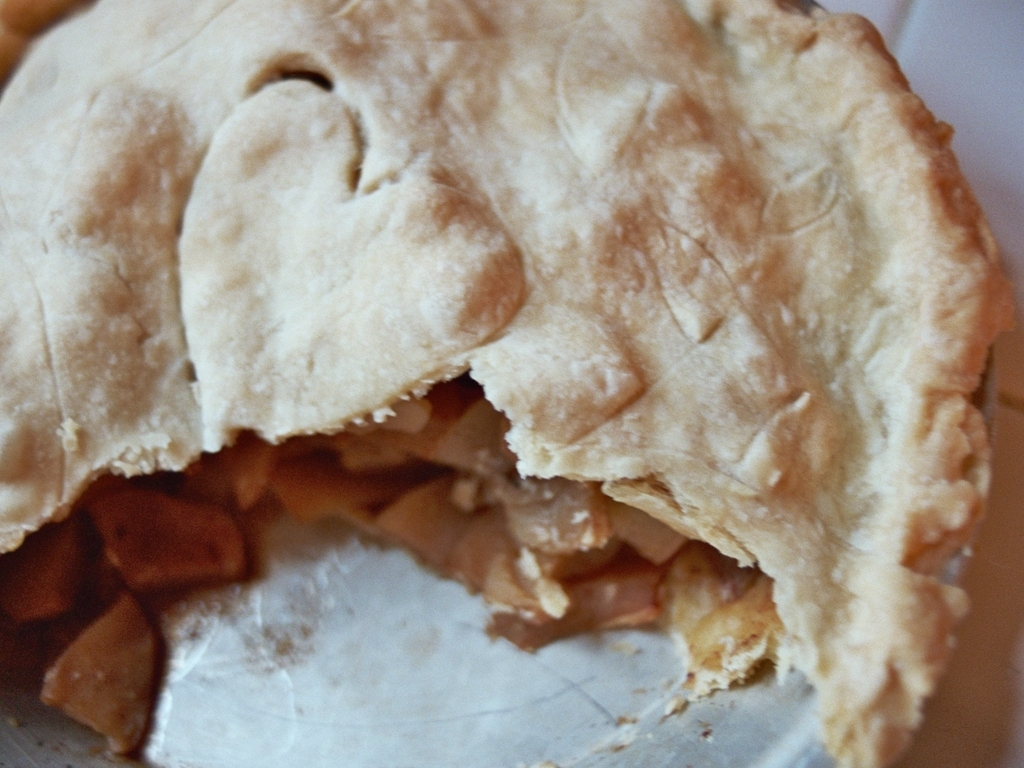Are there any other quality issues in this image? Based on the provided image, there are no apparent quality issues that can be discerned. The image seems to be clear with adequate detail and resolution to make out the content. The photograph showcases a pie with a slice removed, allowing the inside filling to be visible, and no visual defects or issues are observed. 